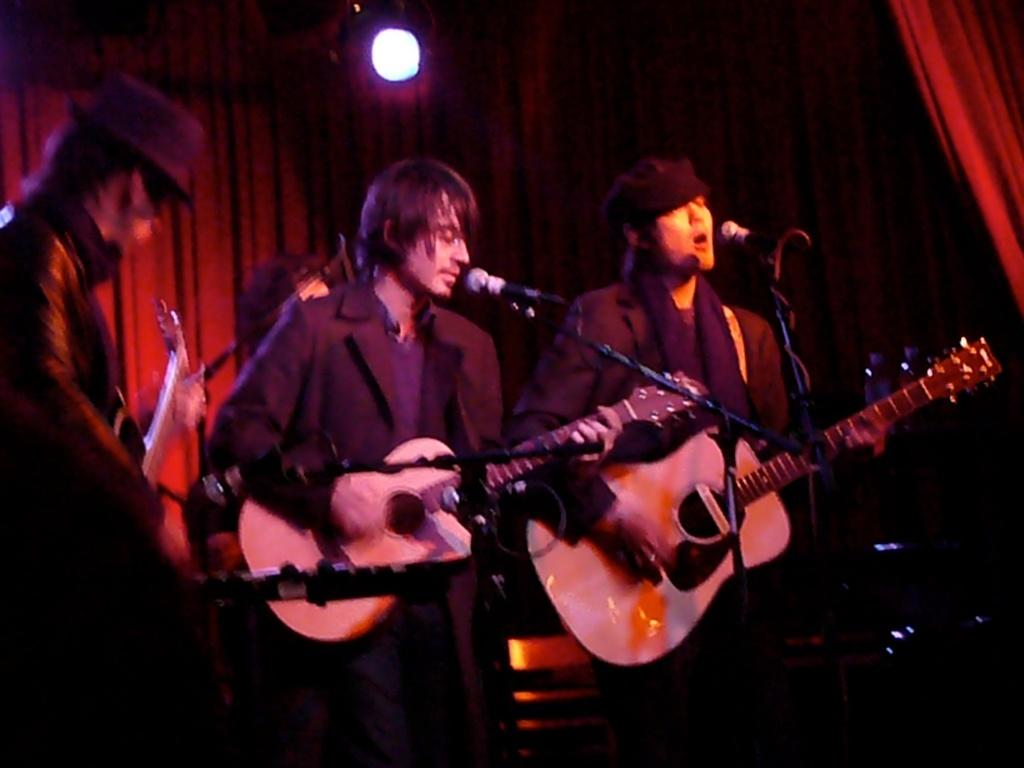How many people are in the image? There are three men in the image. What are the men doing in the image? The men are standing in front of microphones and holding guitars. What can be seen in the background of the image? There is a curtain and lighting visible in the background of the image. What day of the week is shown on the calendar in the image? There is no calendar present in the image. How does the man in the middle kick the soccer ball in the image? There is no soccer ball or kicking action present in the image. 